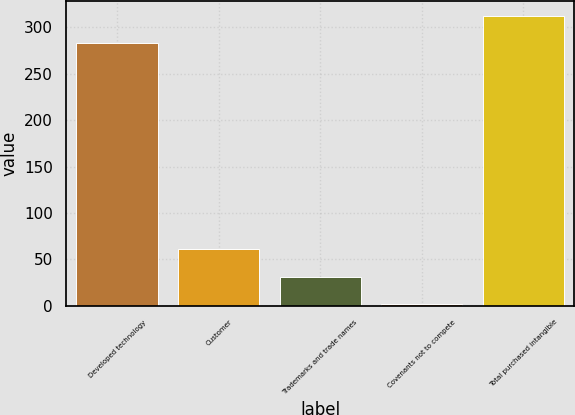Convert chart. <chart><loc_0><loc_0><loc_500><loc_500><bar_chart><fcel>Developed technology<fcel>Customer<fcel>Trademarks and trade names<fcel>Covenants not to compete<fcel>Total purchased intangible<nl><fcel>283<fcel>60.7<fcel>31.15<fcel>1.6<fcel>312.55<nl></chart> 